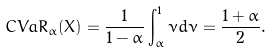Convert formula to latex. <formula><loc_0><loc_0><loc_500><loc_500>C V a R _ { \alpha } ( X ) = \frac { 1 } { 1 - \alpha } \int _ { \alpha } ^ { 1 } \nu d \nu = \frac { 1 + \alpha } { 2 } .</formula> 